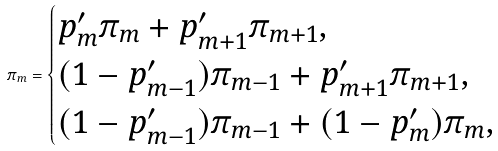<formula> <loc_0><loc_0><loc_500><loc_500>\pi _ { m } = \begin{cases} p ^ { \prime } _ { m } \pi _ { m } + p ^ { \prime } _ { m + 1 } \pi _ { m + 1 } , & \\ ( 1 - p ^ { \prime } _ { m - 1 } ) \pi _ { m - 1 } + p ^ { \prime } _ { m + 1 } \pi _ { m + 1 } , & \\ ( 1 - p ^ { \prime } _ { m - 1 } ) \pi _ { m - 1 } + ( 1 - p ^ { \prime } _ { m } ) \pi _ { m } , & \end{cases}</formula> 